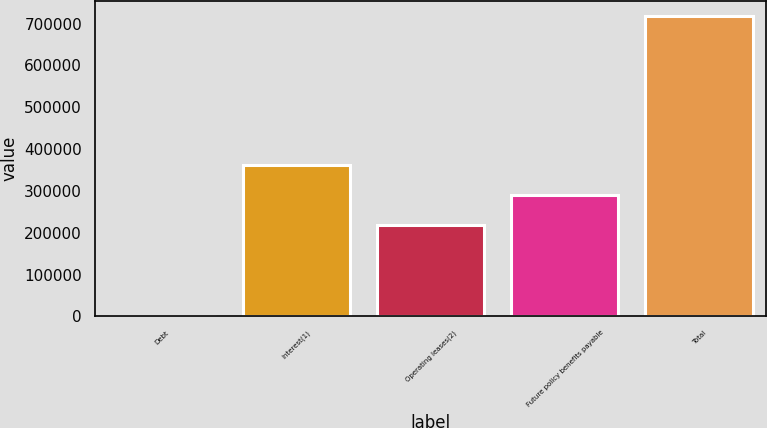Convert chart to OTSL. <chart><loc_0><loc_0><loc_500><loc_500><bar_chart><fcel>Debt<fcel>Interest(1)<fcel>Operating leases(2)<fcel>Future policy benefits payable<fcel>Total<nl><fcel>614<fcel>362293<fcel>218684<fcel>290489<fcel>718661<nl></chart> 